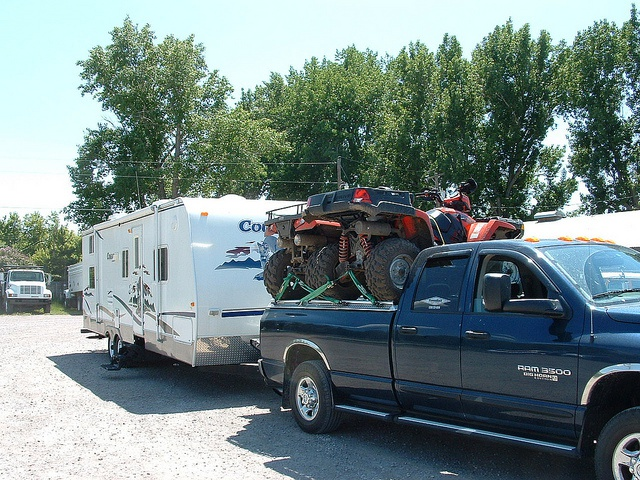Describe the objects in this image and their specific colors. I can see truck in lightblue, black, navy, blue, and gray tones and truck in lightblue, purple, white, darkgray, and gray tones in this image. 